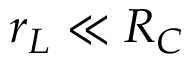Convert formula to latex. <formula><loc_0><loc_0><loc_500><loc_500>r _ { L } \ll R _ { C }</formula> 